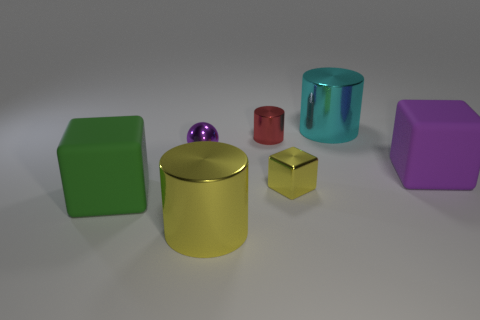What number of large things are either yellow metal cubes or red metallic things?
Keep it short and to the point. 0. How many large purple cubes are behind the large green cube?
Your response must be concise. 1. What is the color of the small shiny object that is the same shape as the large yellow thing?
Provide a short and direct response. Red. What number of matte things are small purple spheres or tiny gray cylinders?
Provide a succinct answer. 0. There is a rubber object that is on the left side of the matte block that is to the right of the big green rubber thing; are there any purple shiny objects that are left of it?
Make the answer very short. No. The tiny sphere has what color?
Your answer should be very brief. Purple. There is a rubber thing that is left of the cyan shiny object; is its shape the same as the purple matte object?
Your response must be concise. Yes. How many things are brown objects or blocks on the right side of the metal ball?
Your answer should be compact. 2. Is the material of the small object that is on the left side of the large yellow object the same as the large yellow cylinder?
Your response must be concise. Yes. Is there anything else that is the same size as the metal cube?
Offer a terse response. Yes. 